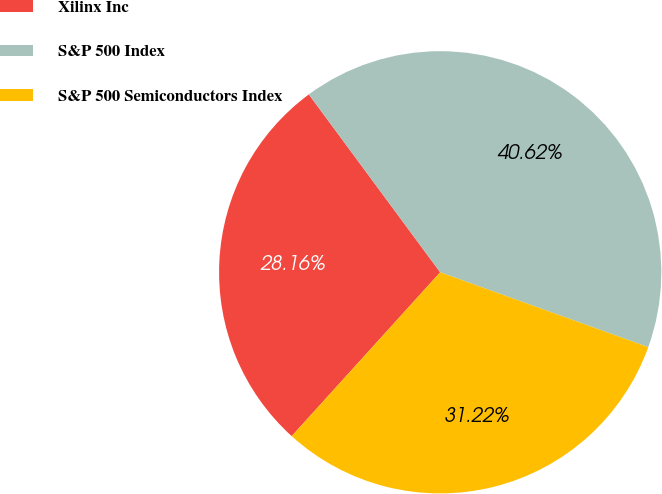<chart> <loc_0><loc_0><loc_500><loc_500><pie_chart><fcel>Xilinx Inc<fcel>S&P 500 Index<fcel>S&P 500 Semiconductors Index<nl><fcel>28.16%<fcel>40.62%<fcel>31.22%<nl></chart> 